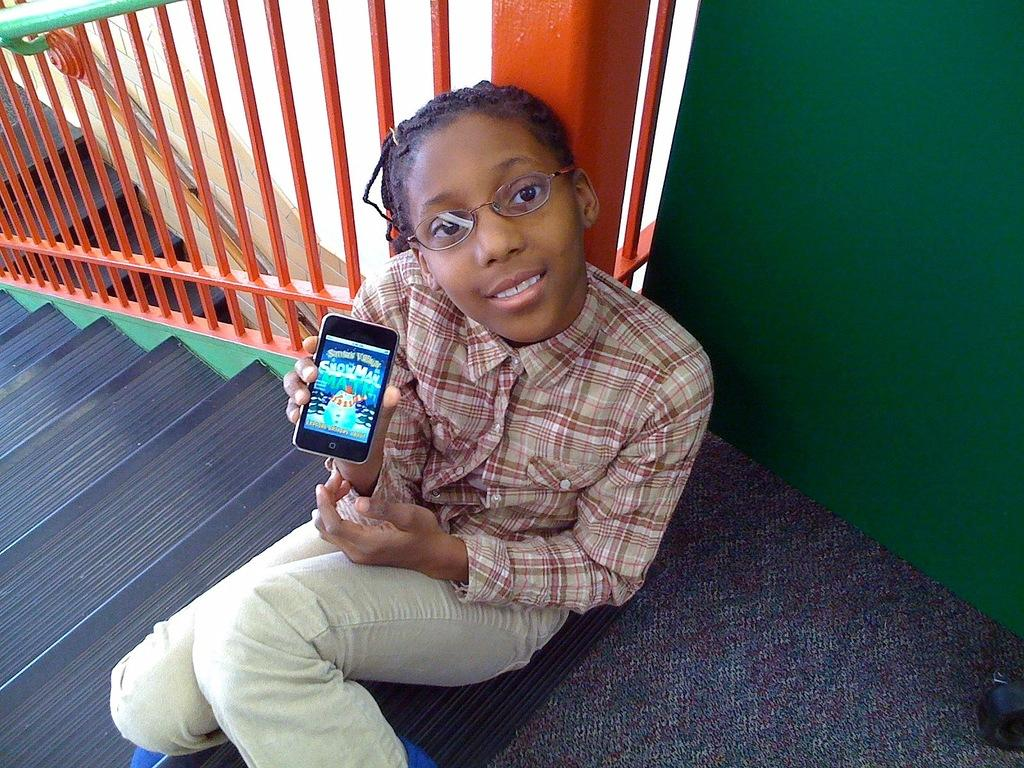What is the girl doing in the image? The girl is sitting on the steps in the image. What is the girl holding in her hand? The girl is holding a mobile phone. What can be seen in the background of the image? There is a railing in the background of the image. What is the color of the railing? The railing is orange in color. What type of print can be seen on the girl's shirt in the image? There is no information about the girl's shirt in the provided facts, so we cannot determine if there is any print on it. 